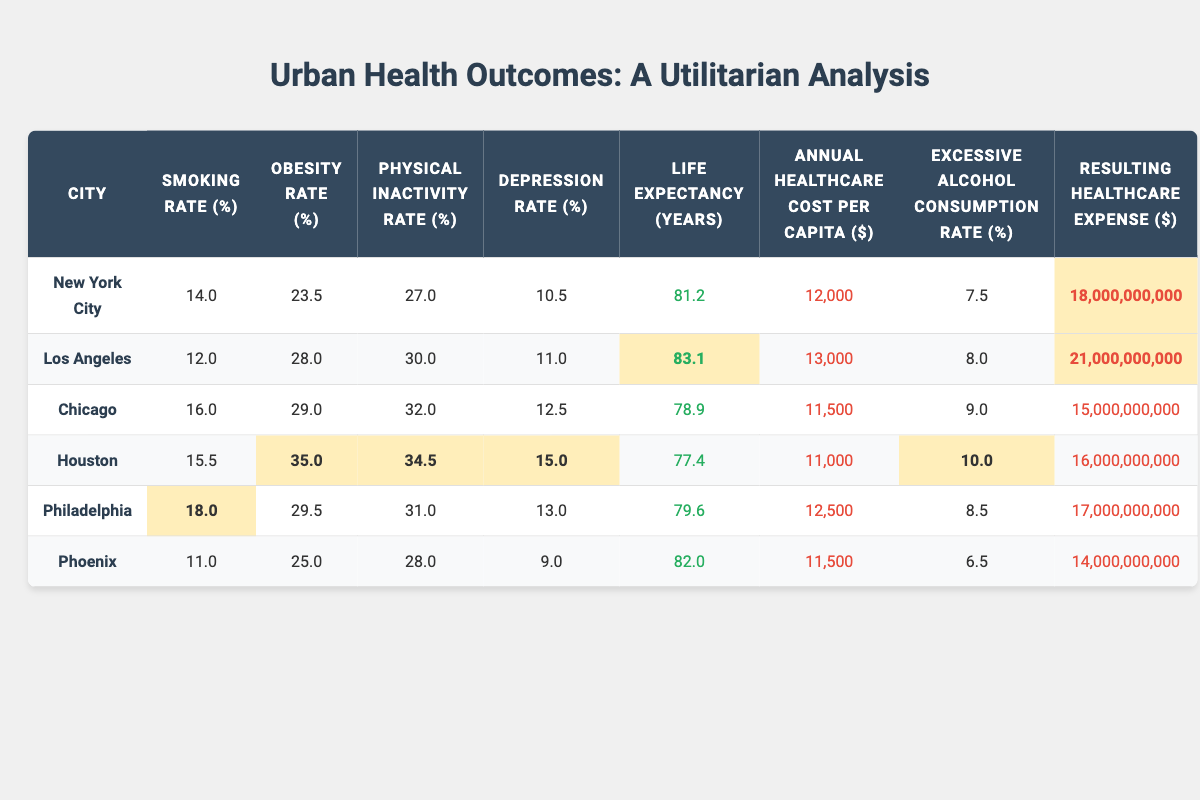What is the life expectancy in Los Angeles? The life expectancy for Los Angeles is listed in the table under the "Life Expectancy (years)" column, which states it is 83.1 years.
Answer: 83.1 years Which city has the highest obesity rate? By examining the obesity rate column, Houston has the highest rate at 35.0%.
Answer: Houston What is the difference in annual healthcare cost per capita between Chicago and New York City? From the table, Chicago's annual healthcare cost is $11,500 and New York City's is $12,000. The difference is $12,000 - $11,500 = $500.
Answer: $500 True or False: Philadelphia has a higher smoking rate than Chicago. The smoking rate for Philadelphia is 18.0%, while Chicago's is 16.0%. Since 18.0% is greater than 16.0%, the statement is True.
Answer: True What is the average physical inactivity rate for the cities listed? To find the average physical inactivity rate, add the rates: 27.0 + 30.0 + 32.0 + 34.5 + 31.0 + 28.0 = 182.5, then divide by 6 (the number of cities), giving an average of 182.5 / 6 = 30.42.
Answer: 30.42% Which city has the lowest annual healthcare expenses listed? Referring to the "Resulting Healthcare Expense" column, Phoenix has the lowest total at $14,000,000,000.
Answer: Phoenix Is the excessive alcohol consumption rate in Houston higher than in New York City? Houston's excessive alcohol consumption rate is 10.0%, while New York City's is 7.5%. Since 10.0% is greater than 7.5%, the answer is yes.
Answer: Yes What are the total healthcare expenses for cities with an obesity rate above 30%? The cities with obesity rates above 30% are Los Angeles, Chicago, Houston, and Philadelphia. Their expenses are: $21,000,000,000 (Los Angeles) + $15,000,000,000 (Chicago) + $16,000,000,000 (Houston) + $17,000,000,000 (Philadelphia) = $69,000,000,000.
Answer: $69,000,000,000 What is the average life expectancy for all the cities listed? The life expectancy values are 81.2, 83.1, 78.9, 77.4, 79.6, and 82.0. Adding these gives 482.2, dividing by 6 gives an average of 80.37.
Answer: 80.37 years Are there any cities with a depression rate above 13%? By checking the depression rate, we find Houston at 15.0% and Philadelphia at 13.0%. Thus, both Houston and Philadelphia have rates that meet this criterion.
Answer: Yes What is the percentage of cities with a smoking rate below 15%? Three cities have smoking rates below 15%: Los Angeles (12.0%), New York City (14.0%), and Phoenix (11.0%). With 6 total cities, the percentage is (3/6) * 100 = 50%.
Answer: 50% 